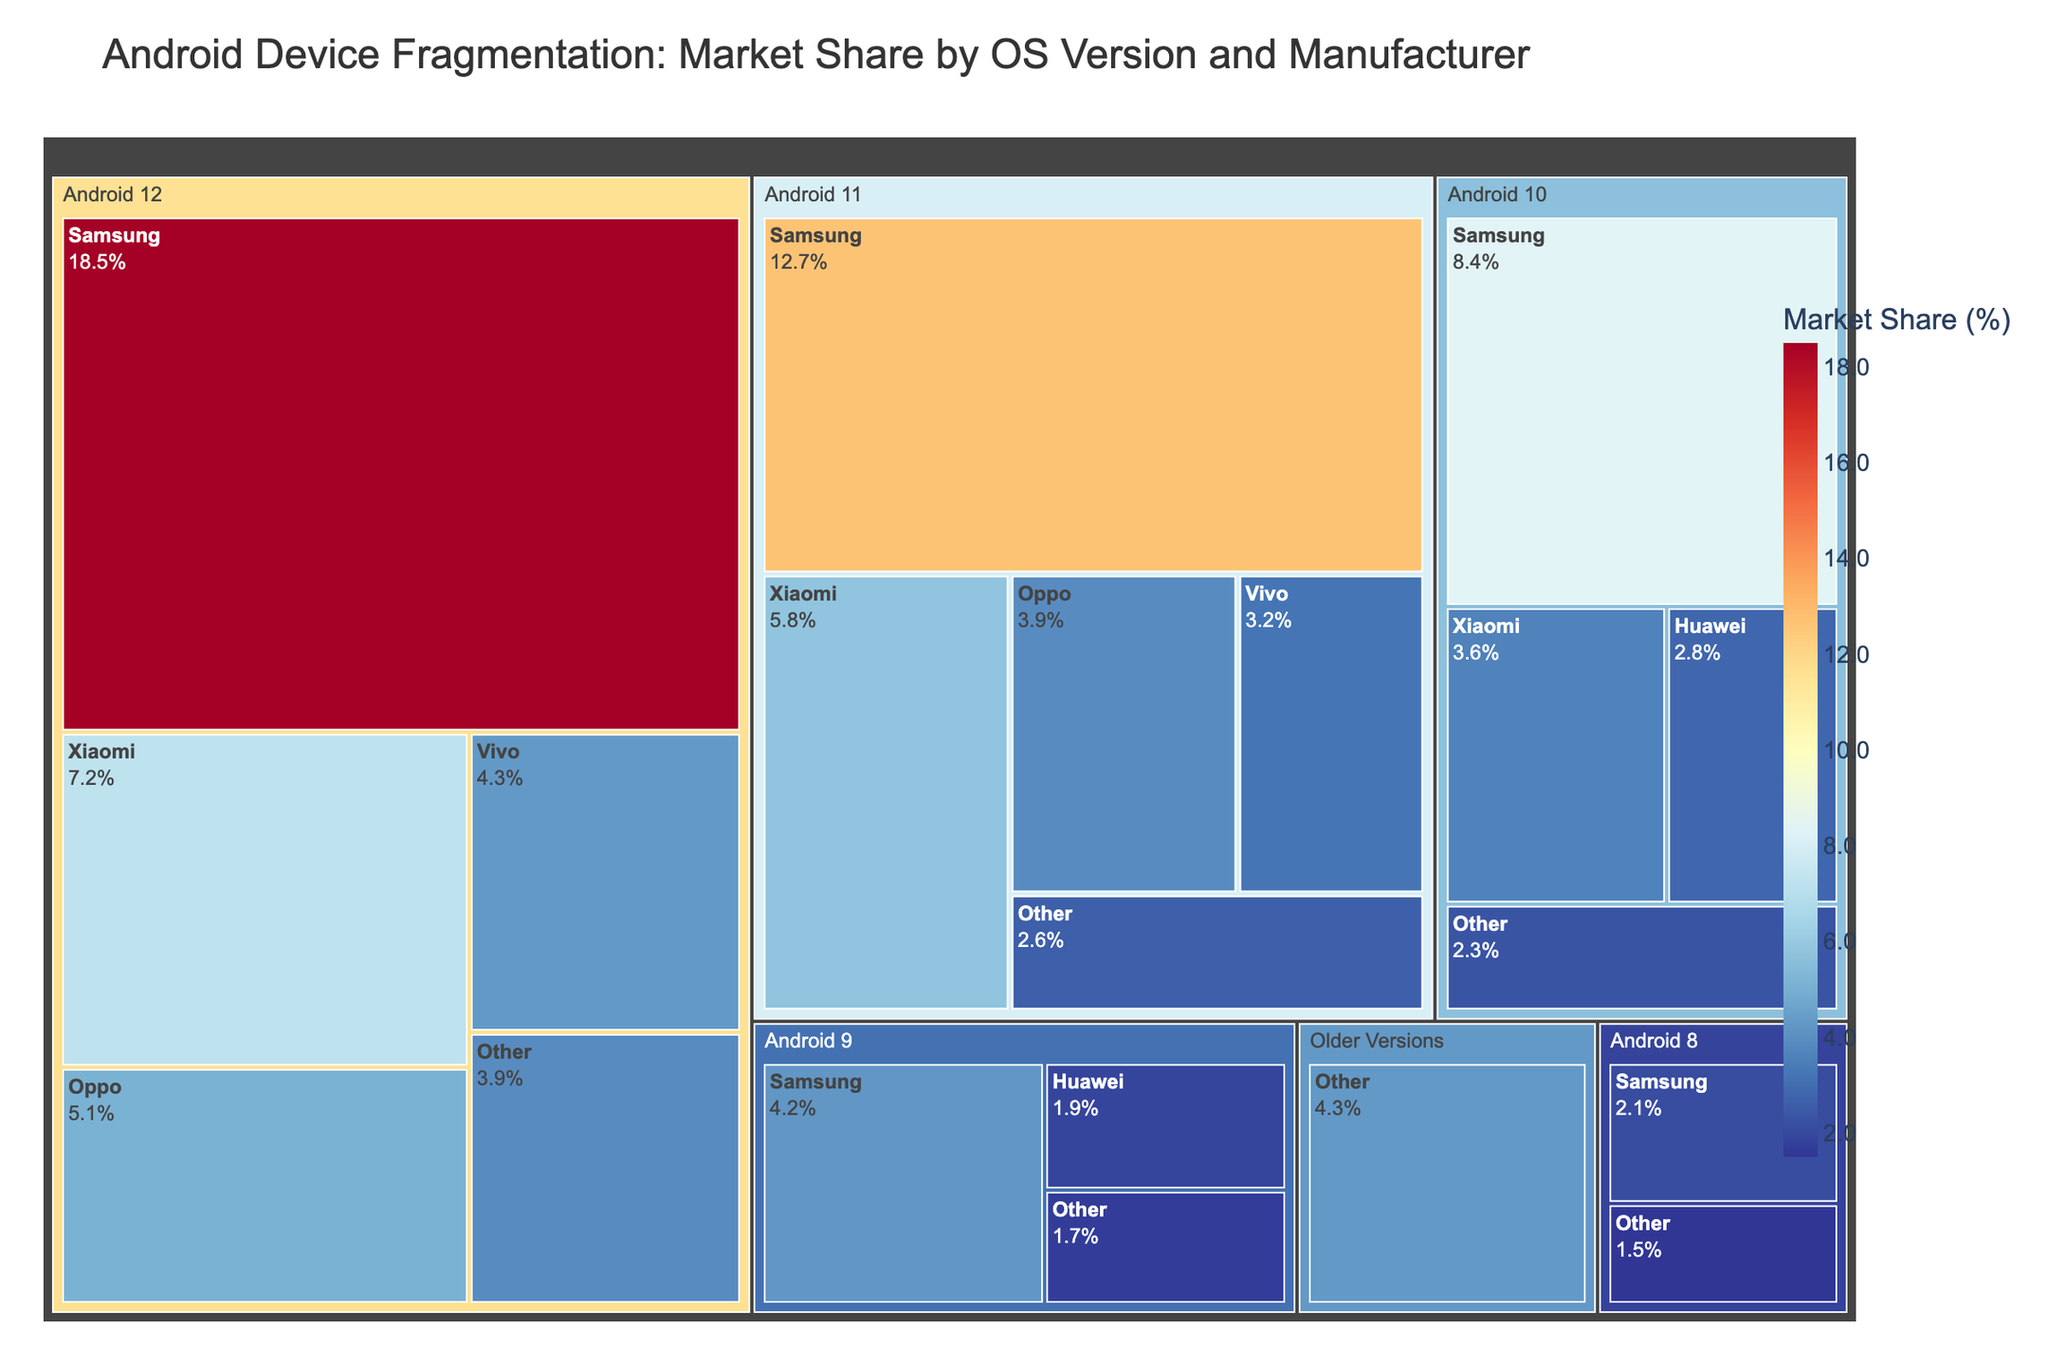What is the title of the treemap? The title of the treemap is displayed at the top of the figure and serves as a summary of the data presented. In this case, it describes the topic of the treemap, which is about market share by OS version and device manufacturer.
Answer: Android Device Fragmentation: Market Share by OS Version and Manufacturer Which OS version has the highest market share? To find the OS version with the highest market share, look for the largest segment in terms of size on the treemap. This is typically represented by the largest outer rectangle.
Answer: Android 12 Which manufacturer has the largest market share within Android 11? Focus on the segment within the Android 11 region, and identify the largest sub-segment. The size of the rectangle indicates the market share.
Answer: Samsung What is the combined market share of Vivo across all OS versions? Sum up the market share of Vivo under each available OS version. Vivo has 4.3% for Android 12 and 3.2% for Android 11. Combine these values.
Answer: 7.5% How does the market share of Samsung for Android 10 compare to that for Android 12? Compare the market share values of Samsung under Android 10 and Android 12 as presented in the figure. Samsung has 8.4% for Android 10 and 18.5% for Android 12.
Answer: Samsung's market share for Android 12 is higher than for Android 10 What is the smallest market share value displayed in the treemap? Identify the smallest rectangle (the smallest market share) among all segments in the treemap, noting that we should check each OS version and manufacturer combination.
Answer: 1.5% (Other under Android 8) How many manufacturers are represented under Android 9? Count the number of distinct segments within the Android 9 section of the treemap.
Answer: 3 (Samsung, Huawei, and Other) Which OS version has the least diversity in terms of the number of manufacturers? Determine the OS version with the fewest number of distinct manufacturer segments.
Answer: Android 8 What is the total market share of manufacturers labeled as "Other" across all OS versions? Sum the market share of manufacturers labeled as "Other" in each OS version available. Other has 3.9% for Android 12, 2.6% for Android 11, 2.3% for Android 10, 1.7% for Android 9, 1.5% for Android 8, and 4.3% for Older Versions.
Answer: 16.3% Which OS version is more fragmented based on the number of manufacturers: Android 12 or Android 11? Compare the number of distinct manufacturer segments present under both Android 12 and Android 11.
Answer: Android 12 (5 manufacturers) is more fragmented than Android 11 (5 manufacturers) 